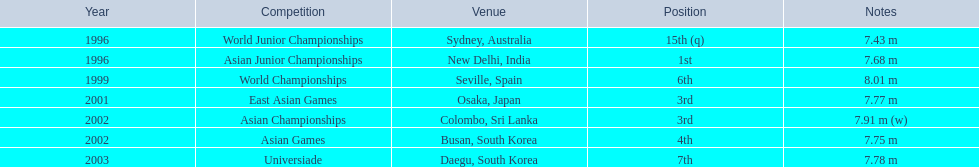In which event did huang le obtain 3rd rank? East Asian Games. In which event did he obtain 4th rank? Asian Games. When did he accomplish 1st rank? Asian Junior Championships. 